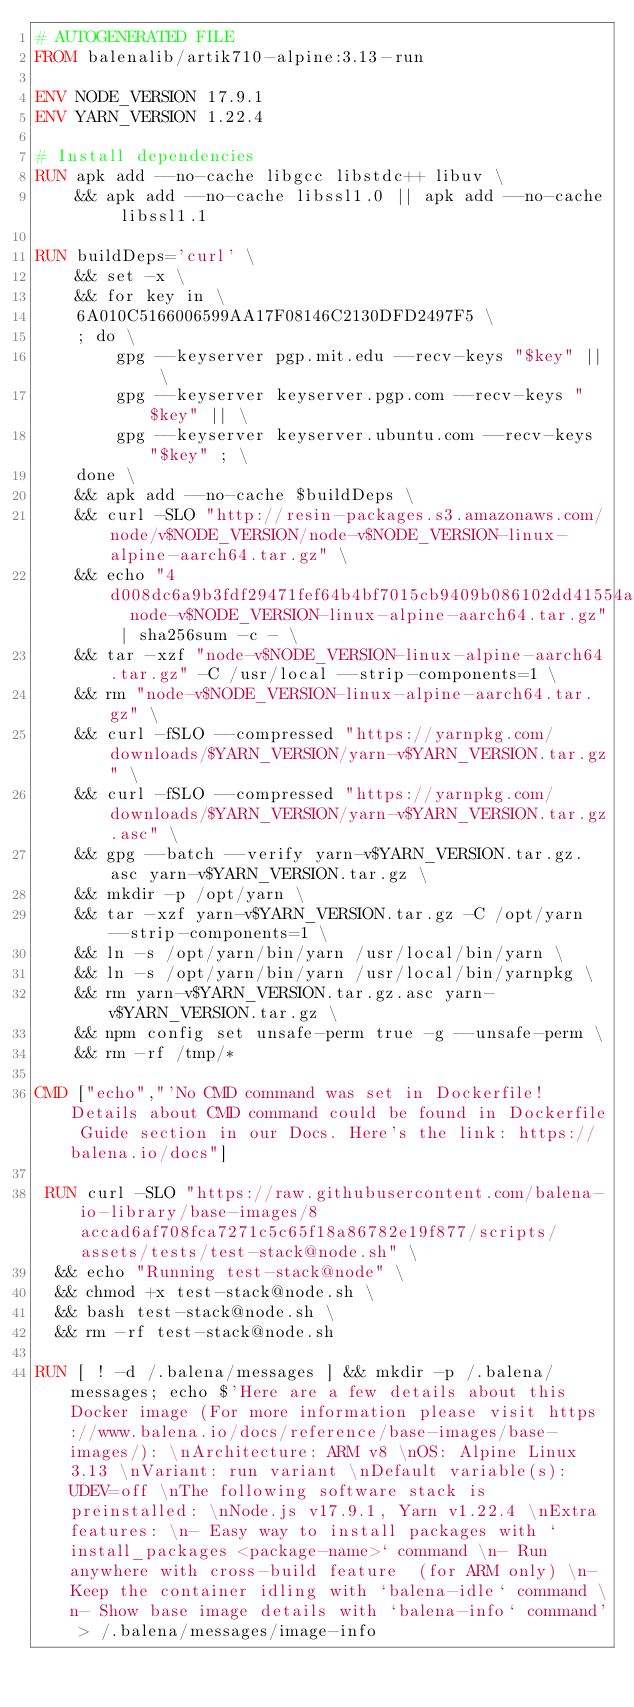Convert code to text. <code><loc_0><loc_0><loc_500><loc_500><_Dockerfile_># AUTOGENERATED FILE
FROM balenalib/artik710-alpine:3.13-run

ENV NODE_VERSION 17.9.1
ENV YARN_VERSION 1.22.4

# Install dependencies
RUN apk add --no-cache libgcc libstdc++ libuv \
	&& apk add --no-cache libssl1.0 || apk add --no-cache libssl1.1

RUN buildDeps='curl' \
	&& set -x \
	&& for key in \
	6A010C5166006599AA17F08146C2130DFD2497F5 \
	; do \
		gpg --keyserver pgp.mit.edu --recv-keys "$key" || \
		gpg --keyserver keyserver.pgp.com --recv-keys "$key" || \
		gpg --keyserver keyserver.ubuntu.com --recv-keys "$key" ; \
	done \
	&& apk add --no-cache $buildDeps \
	&& curl -SLO "http://resin-packages.s3.amazonaws.com/node/v$NODE_VERSION/node-v$NODE_VERSION-linux-alpine-aarch64.tar.gz" \
	&& echo "4d008dc6a9b3fdf29471fef64b4bf7015cb9409b086102dd41554abe72bb3770  node-v$NODE_VERSION-linux-alpine-aarch64.tar.gz" | sha256sum -c - \
	&& tar -xzf "node-v$NODE_VERSION-linux-alpine-aarch64.tar.gz" -C /usr/local --strip-components=1 \
	&& rm "node-v$NODE_VERSION-linux-alpine-aarch64.tar.gz" \
	&& curl -fSLO --compressed "https://yarnpkg.com/downloads/$YARN_VERSION/yarn-v$YARN_VERSION.tar.gz" \
	&& curl -fSLO --compressed "https://yarnpkg.com/downloads/$YARN_VERSION/yarn-v$YARN_VERSION.tar.gz.asc" \
	&& gpg --batch --verify yarn-v$YARN_VERSION.tar.gz.asc yarn-v$YARN_VERSION.tar.gz \
	&& mkdir -p /opt/yarn \
	&& tar -xzf yarn-v$YARN_VERSION.tar.gz -C /opt/yarn --strip-components=1 \
	&& ln -s /opt/yarn/bin/yarn /usr/local/bin/yarn \
	&& ln -s /opt/yarn/bin/yarn /usr/local/bin/yarnpkg \
	&& rm yarn-v$YARN_VERSION.tar.gz.asc yarn-v$YARN_VERSION.tar.gz \
	&& npm config set unsafe-perm true -g --unsafe-perm \
	&& rm -rf /tmp/*

CMD ["echo","'No CMD command was set in Dockerfile! Details about CMD command could be found in Dockerfile Guide section in our Docs. Here's the link: https://balena.io/docs"]

 RUN curl -SLO "https://raw.githubusercontent.com/balena-io-library/base-images/8accad6af708fca7271c5c65f18a86782e19f877/scripts/assets/tests/test-stack@node.sh" \
  && echo "Running test-stack@node" \
  && chmod +x test-stack@node.sh \
  && bash test-stack@node.sh \
  && rm -rf test-stack@node.sh 

RUN [ ! -d /.balena/messages ] && mkdir -p /.balena/messages; echo $'Here are a few details about this Docker image (For more information please visit https://www.balena.io/docs/reference/base-images/base-images/): \nArchitecture: ARM v8 \nOS: Alpine Linux 3.13 \nVariant: run variant \nDefault variable(s): UDEV=off \nThe following software stack is preinstalled: \nNode.js v17.9.1, Yarn v1.22.4 \nExtra features: \n- Easy way to install packages with `install_packages <package-name>` command \n- Run anywhere with cross-build feature  (for ARM only) \n- Keep the container idling with `balena-idle` command \n- Show base image details with `balena-info` command' > /.balena/messages/image-info</code> 